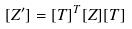Convert formula to latex. <formula><loc_0><loc_0><loc_500><loc_500>[ Z ^ { \prime } ] = { [ T ] } ^ { T } [ Z ] [ T ]</formula> 